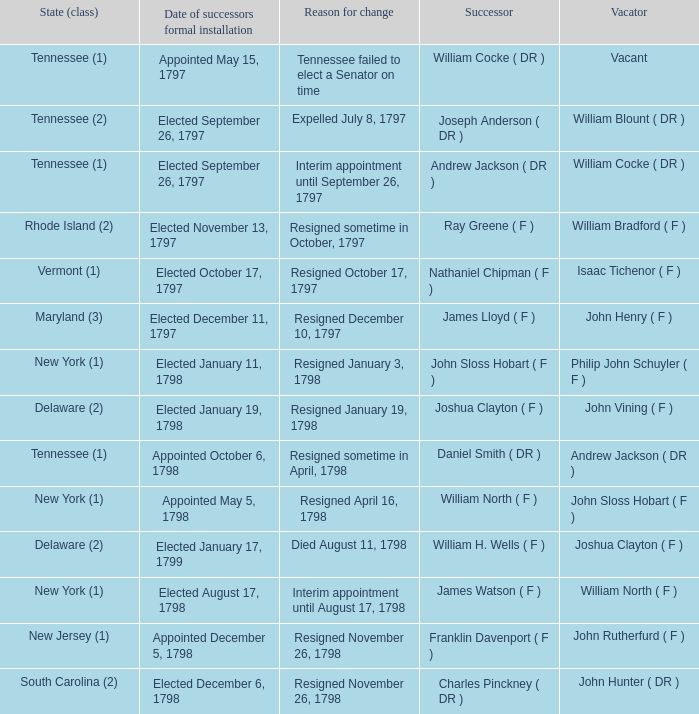What is the total number of dates of successor formal installation when the vacator was Joshua Clayton ( F )? 1.0. 